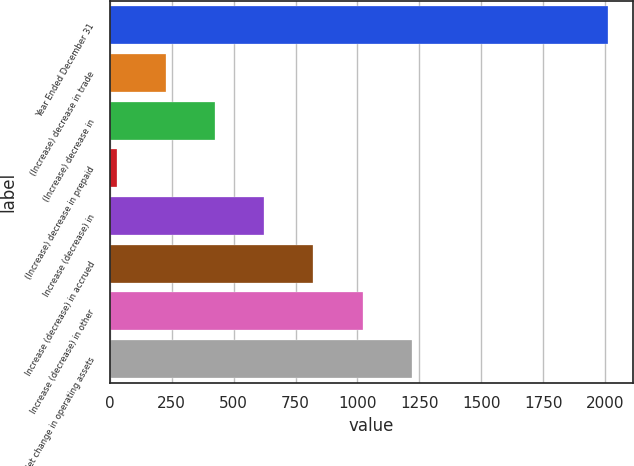Convert chart to OTSL. <chart><loc_0><loc_0><loc_500><loc_500><bar_chart><fcel>Year Ended December 31<fcel>(Increase) decrease in trade<fcel>(Increase) decrease in<fcel>(Increase) decrease in prepaid<fcel>Increase (decrease) in<fcel>Increase (decrease) in accrued<fcel>Increase (decrease) in other<fcel>Net change in operating assets<nl><fcel>2012<fcel>227.3<fcel>425.6<fcel>29<fcel>623.9<fcel>822.2<fcel>1020.5<fcel>1218.8<nl></chart> 